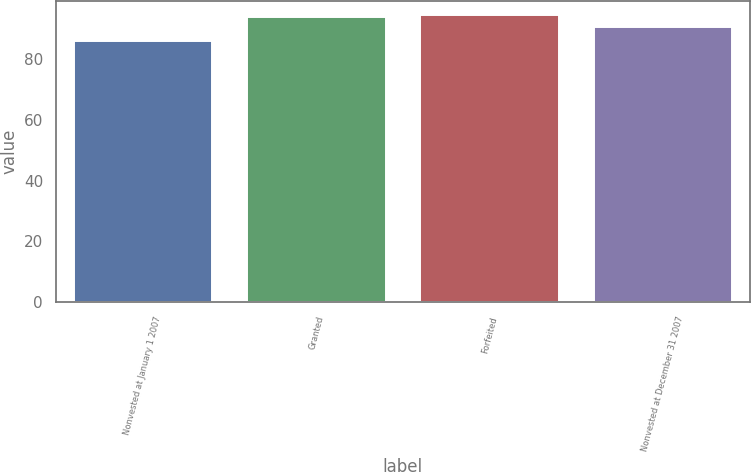Convert chart. <chart><loc_0><loc_0><loc_500><loc_500><bar_chart><fcel>Nonvested at January 1 2007<fcel>Granted<fcel>Forfeited<fcel>Nonvested at December 31 2007<nl><fcel>86.05<fcel>93.72<fcel>94.49<fcel>90.53<nl></chart> 